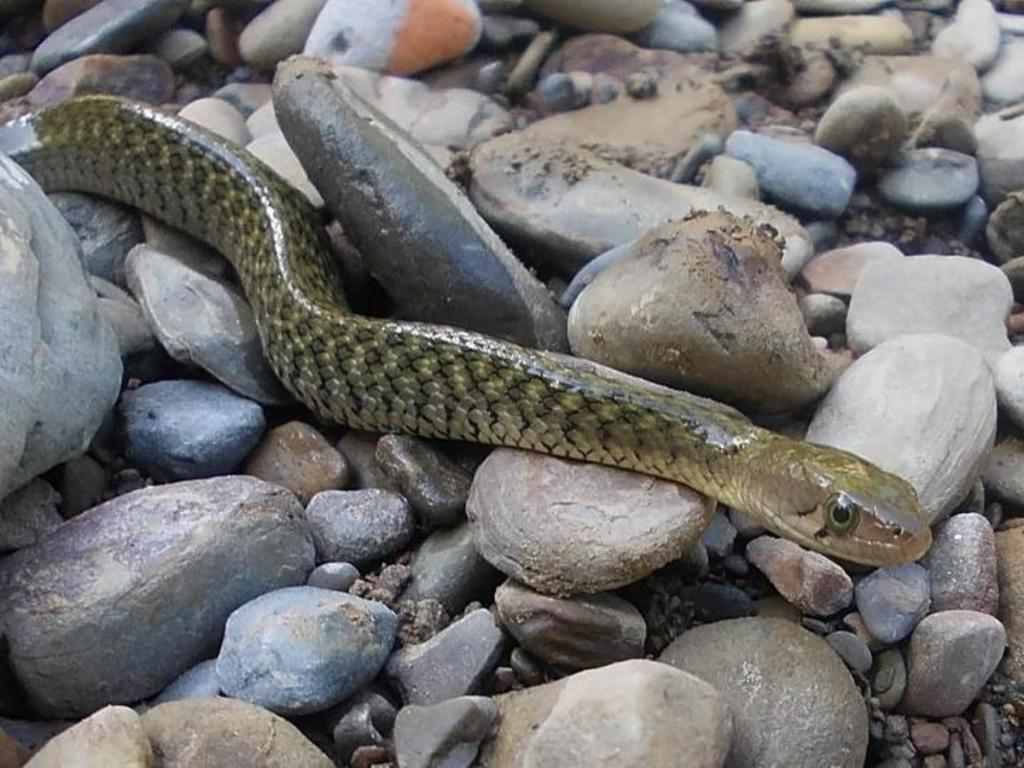What animal is present in the image? There is a snake in the image. What is the snake resting on? The snake is on stones. What type of popcorn is being used to create the art in the image? There is no popcorn or art present in the image; it only features a snake on stones. 